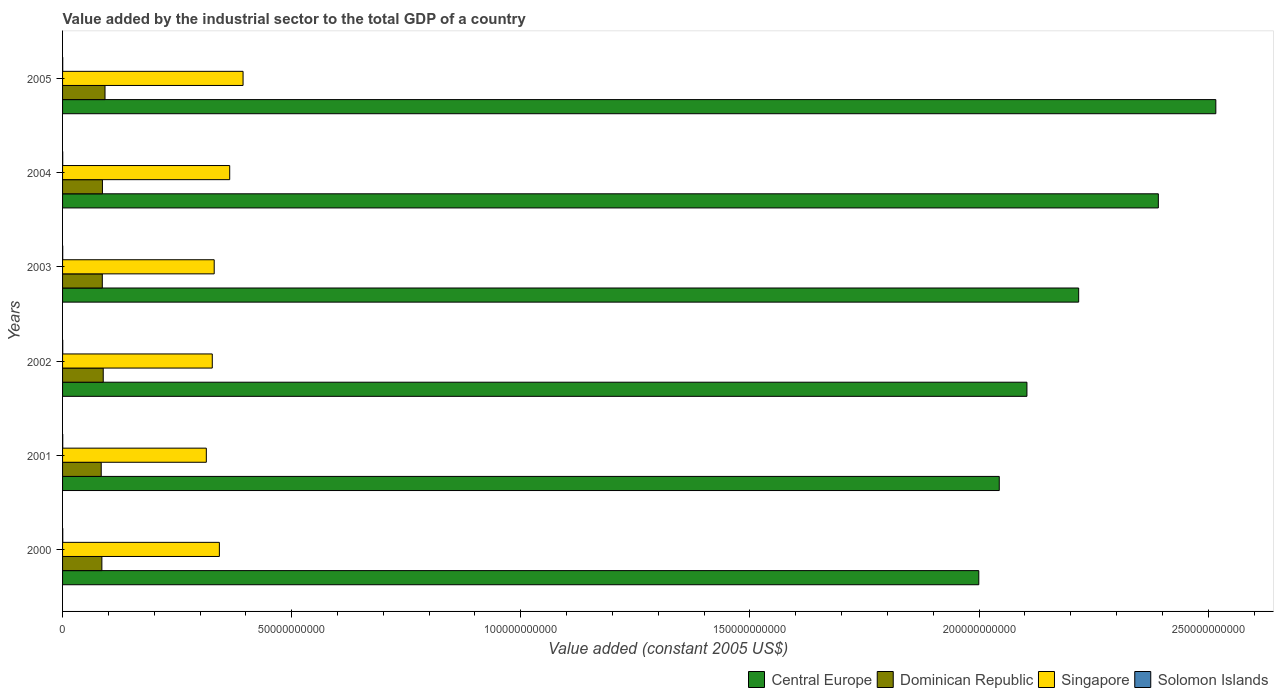Are the number of bars on each tick of the Y-axis equal?
Give a very brief answer. Yes. How many bars are there on the 2nd tick from the top?
Your answer should be compact. 4. What is the label of the 3rd group of bars from the top?
Your answer should be very brief. 2003. What is the value added by the industrial sector in Dominican Republic in 2005?
Keep it short and to the point. 9.26e+09. Across all years, what is the maximum value added by the industrial sector in Solomon Islands?
Keep it short and to the point. 4.19e+07. Across all years, what is the minimum value added by the industrial sector in Solomon Islands?
Your response must be concise. 3.20e+07. In which year was the value added by the industrial sector in Central Europe maximum?
Ensure brevity in your answer.  2005. In which year was the value added by the industrial sector in Singapore minimum?
Your response must be concise. 2001. What is the total value added by the industrial sector in Dominican Republic in the graph?
Make the answer very short. 5.25e+1. What is the difference between the value added by the industrial sector in Singapore in 2001 and that in 2005?
Your response must be concise. -8.01e+09. What is the difference between the value added by the industrial sector in Central Europe in 2005 and the value added by the industrial sector in Solomon Islands in 2000?
Keep it short and to the point. 2.52e+11. What is the average value added by the industrial sector in Dominican Republic per year?
Provide a short and direct response. 8.75e+09. In the year 2005, what is the difference between the value added by the industrial sector in Dominican Republic and value added by the industrial sector in Central Europe?
Your response must be concise. -2.42e+11. In how many years, is the value added by the industrial sector in Singapore greater than 90000000000 US$?
Your answer should be very brief. 0. What is the ratio of the value added by the industrial sector in Singapore in 2000 to that in 2004?
Your response must be concise. 0.94. Is the value added by the industrial sector in Dominican Republic in 2001 less than that in 2003?
Provide a short and direct response. Yes. Is the difference between the value added by the industrial sector in Dominican Republic in 2002 and 2003 greater than the difference between the value added by the industrial sector in Central Europe in 2002 and 2003?
Offer a very short reply. Yes. What is the difference between the highest and the second highest value added by the industrial sector in Dominican Republic?
Give a very brief answer. 3.90e+08. What is the difference between the highest and the lowest value added by the industrial sector in Central Europe?
Provide a short and direct response. 5.17e+1. In how many years, is the value added by the industrial sector in Dominican Republic greater than the average value added by the industrial sector in Dominican Republic taken over all years?
Ensure brevity in your answer.  2. What does the 3rd bar from the top in 2005 represents?
Your answer should be very brief. Dominican Republic. What does the 4th bar from the bottom in 2002 represents?
Provide a succinct answer. Solomon Islands. Is it the case that in every year, the sum of the value added by the industrial sector in Solomon Islands and value added by the industrial sector in Dominican Republic is greater than the value added by the industrial sector in Central Europe?
Ensure brevity in your answer.  No. How many bars are there?
Keep it short and to the point. 24. Are all the bars in the graph horizontal?
Your answer should be compact. Yes. What is the difference between two consecutive major ticks on the X-axis?
Offer a terse response. 5.00e+1. Are the values on the major ticks of X-axis written in scientific E-notation?
Offer a terse response. No. Where does the legend appear in the graph?
Your response must be concise. Bottom right. What is the title of the graph?
Provide a short and direct response. Value added by the industrial sector to the total GDP of a country. What is the label or title of the X-axis?
Your response must be concise. Value added (constant 2005 US$). What is the label or title of the Y-axis?
Give a very brief answer. Years. What is the Value added (constant 2005 US$) of Central Europe in 2000?
Provide a succinct answer. 2.00e+11. What is the Value added (constant 2005 US$) in Dominican Republic in 2000?
Offer a terse response. 8.58e+09. What is the Value added (constant 2005 US$) of Singapore in 2000?
Your answer should be compact. 3.42e+1. What is the Value added (constant 2005 US$) in Solomon Islands in 2000?
Ensure brevity in your answer.  4.19e+07. What is the Value added (constant 2005 US$) of Central Europe in 2001?
Provide a short and direct response. 2.04e+11. What is the Value added (constant 2005 US$) in Dominican Republic in 2001?
Your response must be concise. 8.43e+09. What is the Value added (constant 2005 US$) of Singapore in 2001?
Offer a very short reply. 3.14e+1. What is the Value added (constant 2005 US$) of Solomon Islands in 2001?
Your answer should be very brief. 3.80e+07. What is the Value added (constant 2005 US$) in Central Europe in 2002?
Make the answer very short. 2.10e+11. What is the Value added (constant 2005 US$) of Dominican Republic in 2002?
Give a very brief answer. 8.87e+09. What is the Value added (constant 2005 US$) of Singapore in 2002?
Provide a short and direct response. 3.27e+1. What is the Value added (constant 2005 US$) of Solomon Islands in 2002?
Your response must be concise. 3.70e+07. What is the Value added (constant 2005 US$) of Central Europe in 2003?
Offer a terse response. 2.22e+11. What is the Value added (constant 2005 US$) in Dominican Republic in 2003?
Give a very brief answer. 8.67e+09. What is the Value added (constant 2005 US$) in Singapore in 2003?
Provide a short and direct response. 3.31e+1. What is the Value added (constant 2005 US$) in Solomon Islands in 2003?
Keep it short and to the point. 3.43e+07. What is the Value added (constant 2005 US$) of Central Europe in 2004?
Offer a terse response. 2.39e+11. What is the Value added (constant 2005 US$) of Dominican Republic in 2004?
Provide a succinct answer. 8.70e+09. What is the Value added (constant 2005 US$) in Singapore in 2004?
Make the answer very short. 3.65e+1. What is the Value added (constant 2005 US$) of Solomon Islands in 2004?
Offer a terse response. 3.20e+07. What is the Value added (constant 2005 US$) in Central Europe in 2005?
Offer a terse response. 2.52e+11. What is the Value added (constant 2005 US$) of Dominican Republic in 2005?
Your response must be concise. 9.26e+09. What is the Value added (constant 2005 US$) in Singapore in 2005?
Your response must be concise. 3.94e+1. What is the Value added (constant 2005 US$) of Solomon Islands in 2005?
Your answer should be very brief. 3.29e+07. Across all years, what is the maximum Value added (constant 2005 US$) in Central Europe?
Provide a short and direct response. 2.52e+11. Across all years, what is the maximum Value added (constant 2005 US$) of Dominican Republic?
Offer a very short reply. 9.26e+09. Across all years, what is the maximum Value added (constant 2005 US$) of Singapore?
Keep it short and to the point. 3.94e+1. Across all years, what is the maximum Value added (constant 2005 US$) in Solomon Islands?
Your answer should be compact. 4.19e+07. Across all years, what is the minimum Value added (constant 2005 US$) of Central Europe?
Provide a succinct answer. 2.00e+11. Across all years, what is the minimum Value added (constant 2005 US$) in Dominican Republic?
Your answer should be compact. 8.43e+09. Across all years, what is the minimum Value added (constant 2005 US$) in Singapore?
Make the answer very short. 3.14e+1. Across all years, what is the minimum Value added (constant 2005 US$) of Solomon Islands?
Your answer should be compact. 3.20e+07. What is the total Value added (constant 2005 US$) in Central Europe in the graph?
Provide a succinct answer. 1.33e+12. What is the total Value added (constant 2005 US$) in Dominican Republic in the graph?
Keep it short and to the point. 5.25e+1. What is the total Value added (constant 2005 US$) of Singapore in the graph?
Make the answer very short. 2.07e+11. What is the total Value added (constant 2005 US$) in Solomon Islands in the graph?
Your response must be concise. 2.16e+08. What is the difference between the Value added (constant 2005 US$) in Central Europe in 2000 and that in 2001?
Offer a terse response. -4.47e+09. What is the difference between the Value added (constant 2005 US$) in Dominican Republic in 2000 and that in 2001?
Give a very brief answer. 1.43e+08. What is the difference between the Value added (constant 2005 US$) in Singapore in 2000 and that in 2001?
Make the answer very short. 2.84e+09. What is the difference between the Value added (constant 2005 US$) of Solomon Islands in 2000 and that in 2001?
Your answer should be compact. 3.89e+06. What is the difference between the Value added (constant 2005 US$) in Central Europe in 2000 and that in 2002?
Offer a very short reply. -1.05e+1. What is the difference between the Value added (constant 2005 US$) of Dominican Republic in 2000 and that in 2002?
Give a very brief answer. -2.97e+08. What is the difference between the Value added (constant 2005 US$) of Singapore in 2000 and that in 2002?
Give a very brief answer. 1.55e+09. What is the difference between the Value added (constant 2005 US$) in Solomon Islands in 2000 and that in 2002?
Give a very brief answer. 4.82e+06. What is the difference between the Value added (constant 2005 US$) of Central Europe in 2000 and that in 2003?
Offer a very short reply. -2.18e+1. What is the difference between the Value added (constant 2005 US$) of Dominican Republic in 2000 and that in 2003?
Provide a short and direct response. -9.49e+07. What is the difference between the Value added (constant 2005 US$) of Singapore in 2000 and that in 2003?
Keep it short and to the point. 1.13e+09. What is the difference between the Value added (constant 2005 US$) in Solomon Islands in 2000 and that in 2003?
Offer a very short reply. 7.56e+06. What is the difference between the Value added (constant 2005 US$) in Central Europe in 2000 and that in 2004?
Give a very brief answer. -3.92e+1. What is the difference between the Value added (constant 2005 US$) in Dominican Republic in 2000 and that in 2004?
Keep it short and to the point. -1.23e+08. What is the difference between the Value added (constant 2005 US$) in Singapore in 2000 and that in 2004?
Give a very brief answer. -2.26e+09. What is the difference between the Value added (constant 2005 US$) in Solomon Islands in 2000 and that in 2004?
Keep it short and to the point. 9.82e+06. What is the difference between the Value added (constant 2005 US$) in Central Europe in 2000 and that in 2005?
Offer a terse response. -5.17e+1. What is the difference between the Value added (constant 2005 US$) of Dominican Republic in 2000 and that in 2005?
Your response must be concise. -6.87e+08. What is the difference between the Value added (constant 2005 US$) of Singapore in 2000 and that in 2005?
Your answer should be very brief. -5.17e+09. What is the difference between the Value added (constant 2005 US$) of Solomon Islands in 2000 and that in 2005?
Make the answer very short. 8.97e+06. What is the difference between the Value added (constant 2005 US$) of Central Europe in 2001 and that in 2002?
Keep it short and to the point. -6.04e+09. What is the difference between the Value added (constant 2005 US$) in Dominican Republic in 2001 and that in 2002?
Give a very brief answer. -4.40e+08. What is the difference between the Value added (constant 2005 US$) of Singapore in 2001 and that in 2002?
Provide a succinct answer. -1.30e+09. What is the difference between the Value added (constant 2005 US$) of Solomon Islands in 2001 and that in 2002?
Provide a succinct answer. 9.35e+05. What is the difference between the Value added (constant 2005 US$) in Central Europe in 2001 and that in 2003?
Offer a terse response. -1.73e+1. What is the difference between the Value added (constant 2005 US$) in Dominican Republic in 2001 and that in 2003?
Make the answer very short. -2.38e+08. What is the difference between the Value added (constant 2005 US$) in Singapore in 2001 and that in 2003?
Ensure brevity in your answer.  -1.72e+09. What is the difference between the Value added (constant 2005 US$) of Solomon Islands in 2001 and that in 2003?
Your response must be concise. 3.68e+06. What is the difference between the Value added (constant 2005 US$) in Central Europe in 2001 and that in 2004?
Provide a short and direct response. -3.47e+1. What is the difference between the Value added (constant 2005 US$) in Dominican Republic in 2001 and that in 2004?
Offer a very short reply. -2.65e+08. What is the difference between the Value added (constant 2005 US$) of Singapore in 2001 and that in 2004?
Your answer should be very brief. -5.10e+09. What is the difference between the Value added (constant 2005 US$) in Solomon Islands in 2001 and that in 2004?
Your response must be concise. 5.93e+06. What is the difference between the Value added (constant 2005 US$) in Central Europe in 2001 and that in 2005?
Give a very brief answer. -4.73e+1. What is the difference between the Value added (constant 2005 US$) of Dominican Republic in 2001 and that in 2005?
Your answer should be compact. -8.30e+08. What is the difference between the Value added (constant 2005 US$) of Singapore in 2001 and that in 2005?
Your answer should be compact. -8.01e+09. What is the difference between the Value added (constant 2005 US$) of Solomon Islands in 2001 and that in 2005?
Offer a terse response. 5.08e+06. What is the difference between the Value added (constant 2005 US$) of Central Europe in 2002 and that in 2003?
Offer a terse response. -1.13e+1. What is the difference between the Value added (constant 2005 US$) of Dominican Republic in 2002 and that in 2003?
Your answer should be compact. 2.02e+08. What is the difference between the Value added (constant 2005 US$) in Singapore in 2002 and that in 2003?
Provide a succinct answer. -4.20e+08. What is the difference between the Value added (constant 2005 US$) in Solomon Islands in 2002 and that in 2003?
Your answer should be very brief. 2.74e+06. What is the difference between the Value added (constant 2005 US$) of Central Europe in 2002 and that in 2004?
Offer a terse response. -2.87e+1. What is the difference between the Value added (constant 2005 US$) in Dominican Republic in 2002 and that in 2004?
Offer a very short reply. 1.74e+08. What is the difference between the Value added (constant 2005 US$) in Singapore in 2002 and that in 2004?
Provide a short and direct response. -3.80e+09. What is the difference between the Value added (constant 2005 US$) of Solomon Islands in 2002 and that in 2004?
Your answer should be very brief. 5.00e+06. What is the difference between the Value added (constant 2005 US$) in Central Europe in 2002 and that in 2005?
Make the answer very short. -4.12e+1. What is the difference between the Value added (constant 2005 US$) in Dominican Republic in 2002 and that in 2005?
Your answer should be very brief. -3.90e+08. What is the difference between the Value added (constant 2005 US$) of Singapore in 2002 and that in 2005?
Provide a succinct answer. -6.72e+09. What is the difference between the Value added (constant 2005 US$) of Solomon Islands in 2002 and that in 2005?
Give a very brief answer. 4.15e+06. What is the difference between the Value added (constant 2005 US$) in Central Europe in 2003 and that in 2004?
Your answer should be very brief. -1.74e+1. What is the difference between the Value added (constant 2005 US$) in Dominican Republic in 2003 and that in 2004?
Ensure brevity in your answer.  -2.77e+07. What is the difference between the Value added (constant 2005 US$) of Singapore in 2003 and that in 2004?
Provide a succinct answer. -3.38e+09. What is the difference between the Value added (constant 2005 US$) in Solomon Islands in 2003 and that in 2004?
Keep it short and to the point. 2.26e+06. What is the difference between the Value added (constant 2005 US$) of Central Europe in 2003 and that in 2005?
Your answer should be very brief. -2.99e+1. What is the difference between the Value added (constant 2005 US$) in Dominican Republic in 2003 and that in 2005?
Provide a succinct answer. -5.92e+08. What is the difference between the Value added (constant 2005 US$) in Singapore in 2003 and that in 2005?
Keep it short and to the point. -6.30e+09. What is the difference between the Value added (constant 2005 US$) of Solomon Islands in 2003 and that in 2005?
Your answer should be very brief. 1.41e+06. What is the difference between the Value added (constant 2005 US$) in Central Europe in 2004 and that in 2005?
Your answer should be very brief. -1.25e+1. What is the difference between the Value added (constant 2005 US$) of Dominican Republic in 2004 and that in 2005?
Your answer should be very brief. -5.64e+08. What is the difference between the Value added (constant 2005 US$) of Singapore in 2004 and that in 2005?
Your answer should be very brief. -2.91e+09. What is the difference between the Value added (constant 2005 US$) of Solomon Islands in 2004 and that in 2005?
Ensure brevity in your answer.  -8.51e+05. What is the difference between the Value added (constant 2005 US$) in Central Europe in 2000 and the Value added (constant 2005 US$) in Dominican Republic in 2001?
Provide a succinct answer. 1.92e+11. What is the difference between the Value added (constant 2005 US$) in Central Europe in 2000 and the Value added (constant 2005 US$) in Singapore in 2001?
Your response must be concise. 1.69e+11. What is the difference between the Value added (constant 2005 US$) of Central Europe in 2000 and the Value added (constant 2005 US$) of Solomon Islands in 2001?
Your answer should be compact. 2.00e+11. What is the difference between the Value added (constant 2005 US$) in Dominican Republic in 2000 and the Value added (constant 2005 US$) in Singapore in 2001?
Offer a terse response. -2.28e+1. What is the difference between the Value added (constant 2005 US$) in Dominican Republic in 2000 and the Value added (constant 2005 US$) in Solomon Islands in 2001?
Ensure brevity in your answer.  8.54e+09. What is the difference between the Value added (constant 2005 US$) of Singapore in 2000 and the Value added (constant 2005 US$) of Solomon Islands in 2001?
Make the answer very short. 3.42e+1. What is the difference between the Value added (constant 2005 US$) of Central Europe in 2000 and the Value added (constant 2005 US$) of Dominican Republic in 2002?
Your answer should be very brief. 1.91e+11. What is the difference between the Value added (constant 2005 US$) in Central Europe in 2000 and the Value added (constant 2005 US$) in Singapore in 2002?
Provide a short and direct response. 1.67e+11. What is the difference between the Value added (constant 2005 US$) of Central Europe in 2000 and the Value added (constant 2005 US$) of Solomon Islands in 2002?
Provide a short and direct response. 2.00e+11. What is the difference between the Value added (constant 2005 US$) in Dominican Republic in 2000 and the Value added (constant 2005 US$) in Singapore in 2002?
Provide a succinct answer. -2.41e+1. What is the difference between the Value added (constant 2005 US$) in Dominican Republic in 2000 and the Value added (constant 2005 US$) in Solomon Islands in 2002?
Offer a terse response. 8.54e+09. What is the difference between the Value added (constant 2005 US$) in Singapore in 2000 and the Value added (constant 2005 US$) in Solomon Islands in 2002?
Provide a short and direct response. 3.42e+1. What is the difference between the Value added (constant 2005 US$) in Central Europe in 2000 and the Value added (constant 2005 US$) in Dominican Republic in 2003?
Your answer should be compact. 1.91e+11. What is the difference between the Value added (constant 2005 US$) of Central Europe in 2000 and the Value added (constant 2005 US$) of Singapore in 2003?
Keep it short and to the point. 1.67e+11. What is the difference between the Value added (constant 2005 US$) in Central Europe in 2000 and the Value added (constant 2005 US$) in Solomon Islands in 2003?
Your answer should be very brief. 2.00e+11. What is the difference between the Value added (constant 2005 US$) in Dominican Republic in 2000 and the Value added (constant 2005 US$) in Singapore in 2003?
Offer a terse response. -2.45e+1. What is the difference between the Value added (constant 2005 US$) in Dominican Republic in 2000 and the Value added (constant 2005 US$) in Solomon Islands in 2003?
Offer a very short reply. 8.54e+09. What is the difference between the Value added (constant 2005 US$) in Singapore in 2000 and the Value added (constant 2005 US$) in Solomon Islands in 2003?
Keep it short and to the point. 3.42e+1. What is the difference between the Value added (constant 2005 US$) of Central Europe in 2000 and the Value added (constant 2005 US$) of Dominican Republic in 2004?
Offer a very short reply. 1.91e+11. What is the difference between the Value added (constant 2005 US$) in Central Europe in 2000 and the Value added (constant 2005 US$) in Singapore in 2004?
Offer a very short reply. 1.63e+11. What is the difference between the Value added (constant 2005 US$) in Central Europe in 2000 and the Value added (constant 2005 US$) in Solomon Islands in 2004?
Offer a terse response. 2.00e+11. What is the difference between the Value added (constant 2005 US$) of Dominican Republic in 2000 and the Value added (constant 2005 US$) of Singapore in 2004?
Your answer should be very brief. -2.79e+1. What is the difference between the Value added (constant 2005 US$) in Dominican Republic in 2000 and the Value added (constant 2005 US$) in Solomon Islands in 2004?
Your answer should be compact. 8.55e+09. What is the difference between the Value added (constant 2005 US$) in Singapore in 2000 and the Value added (constant 2005 US$) in Solomon Islands in 2004?
Offer a very short reply. 3.42e+1. What is the difference between the Value added (constant 2005 US$) of Central Europe in 2000 and the Value added (constant 2005 US$) of Dominican Republic in 2005?
Ensure brevity in your answer.  1.91e+11. What is the difference between the Value added (constant 2005 US$) of Central Europe in 2000 and the Value added (constant 2005 US$) of Singapore in 2005?
Make the answer very short. 1.61e+11. What is the difference between the Value added (constant 2005 US$) in Central Europe in 2000 and the Value added (constant 2005 US$) in Solomon Islands in 2005?
Make the answer very short. 2.00e+11. What is the difference between the Value added (constant 2005 US$) of Dominican Republic in 2000 and the Value added (constant 2005 US$) of Singapore in 2005?
Offer a terse response. -3.08e+1. What is the difference between the Value added (constant 2005 US$) in Dominican Republic in 2000 and the Value added (constant 2005 US$) in Solomon Islands in 2005?
Ensure brevity in your answer.  8.54e+09. What is the difference between the Value added (constant 2005 US$) in Singapore in 2000 and the Value added (constant 2005 US$) in Solomon Islands in 2005?
Provide a short and direct response. 3.42e+1. What is the difference between the Value added (constant 2005 US$) of Central Europe in 2001 and the Value added (constant 2005 US$) of Dominican Republic in 2002?
Your response must be concise. 1.96e+11. What is the difference between the Value added (constant 2005 US$) in Central Europe in 2001 and the Value added (constant 2005 US$) in Singapore in 2002?
Ensure brevity in your answer.  1.72e+11. What is the difference between the Value added (constant 2005 US$) of Central Europe in 2001 and the Value added (constant 2005 US$) of Solomon Islands in 2002?
Offer a very short reply. 2.04e+11. What is the difference between the Value added (constant 2005 US$) in Dominican Republic in 2001 and the Value added (constant 2005 US$) in Singapore in 2002?
Make the answer very short. -2.42e+1. What is the difference between the Value added (constant 2005 US$) in Dominican Republic in 2001 and the Value added (constant 2005 US$) in Solomon Islands in 2002?
Keep it short and to the point. 8.40e+09. What is the difference between the Value added (constant 2005 US$) in Singapore in 2001 and the Value added (constant 2005 US$) in Solomon Islands in 2002?
Make the answer very short. 3.13e+1. What is the difference between the Value added (constant 2005 US$) in Central Europe in 2001 and the Value added (constant 2005 US$) in Dominican Republic in 2003?
Give a very brief answer. 1.96e+11. What is the difference between the Value added (constant 2005 US$) of Central Europe in 2001 and the Value added (constant 2005 US$) of Singapore in 2003?
Offer a terse response. 1.71e+11. What is the difference between the Value added (constant 2005 US$) in Central Europe in 2001 and the Value added (constant 2005 US$) in Solomon Islands in 2003?
Your response must be concise. 2.04e+11. What is the difference between the Value added (constant 2005 US$) of Dominican Republic in 2001 and the Value added (constant 2005 US$) of Singapore in 2003?
Your answer should be compact. -2.47e+1. What is the difference between the Value added (constant 2005 US$) in Dominican Republic in 2001 and the Value added (constant 2005 US$) in Solomon Islands in 2003?
Your answer should be compact. 8.40e+09. What is the difference between the Value added (constant 2005 US$) in Singapore in 2001 and the Value added (constant 2005 US$) in Solomon Islands in 2003?
Offer a very short reply. 3.13e+1. What is the difference between the Value added (constant 2005 US$) of Central Europe in 2001 and the Value added (constant 2005 US$) of Dominican Republic in 2004?
Your response must be concise. 1.96e+11. What is the difference between the Value added (constant 2005 US$) in Central Europe in 2001 and the Value added (constant 2005 US$) in Singapore in 2004?
Your answer should be compact. 1.68e+11. What is the difference between the Value added (constant 2005 US$) of Central Europe in 2001 and the Value added (constant 2005 US$) of Solomon Islands in 2004?
Your response must be concise. 2.04e+11. What is the difference between the Value added (constant 2005 US$) in Dominican Republic in 2001 and the Value added (constant 2005 US$) in Singapore in 2004?
Offer a terse response. -2.80e+1. What is the difference between the Value added (constant 2005 US$) of Dominican Republic in 2001 and the Value added (constant 2005 US$) of Solomon Islands in 2004?
Make the answer very short. 8.40e+09. What is the difference between the Value added (constant 2005 US$) of Singapore in 2001 and the Value added (constant 2005 US$) of Solomon Islands in 2004?
Provide a succinct answer. 3.13e+1. What is the difference between the Value added (constant 2005 US$) in Central Europe in 2001 and the Value added (constant 2005 US$) in Dominican Republic in 2005?
Your answer should be compact. 1.95e+11. What is the difference between the Value added (constant 2005 US$) of Central Europe in 2001 and the Value added (constant 2005 US$) of Singapore in 2005?
Provide a succinct answer. 1.65e+11. What is the difference between the Value added (constant 2005 US$) of Central Europe in 2001 and the Value added (constant 2005 US$) of Solomon Islands in 2005?
Your answer should be very brief. 2.04e+11. What is the difference between the Value added (constant 2005 US$) in Dominican Republic in 2001 and the Value added (constant 2005 US$) in Singapore in 2005?
Provide a succinct answer. -3.10e+1. What is the difference between the Value added (constant 2005 US$) in Dominican Republic in 2001 and the Value added (constant 2005 US$) in Solomon Islands in 2005?
Your answer should be compact. 8.40e+09. What is the difference between the Value added (constant 2005 US$) in Singapore in 2001 and the Value added (constant 2005 US$) in Solomon Islands in 2005?
Give a very brief answer. 3.13e+1. What is the difference between the Value added (constant 2005 US$) of Central Europe in 2002 and the Value added (constant 2005 US$) of Dominican Republic in 2003?
Make the answer very short. 2.02e+11. What is the difference between the Value added (constant 2005 US$) of Central Europe in 2002 and the Value added (constant 2005 US$) of Singapore in 2003?
Your response must be concise. 1.77e+11. What is the difference between the Value added (constant 2005 US$) of Central Europe in 2002 and the Value added (constant 2005 US$) of Solomon Islands in 2003?
Your answer should be very brief. 2.10e+11. What is the difference between the Value added (constant 2005 US$) of Dominican Republic in 2002 and the Value added (constant 2005 US$) of Singapore in 2003?
Ensure brevity in your answer.  -2.42e+1. What is the difference between the Value added (constant 2005 US$) in Dominican Republic in 2002 and the Value added (constant 2005 US$) in Solomon Islands in 2003?
Your answer should be very brief. 8.84e+09. What is the difference between the Value added (constant 2005 US$) of Singapore in 2002 and the Value added (constant 2005 US$) of Solomon Islands in 2003?
Provide a short and direct response. 3.26e+1. What is the difference between the Value added (constant 2005 US$) of Central Europe in 2002 and the Value added (constant 2005 US$) of Dominican Republic in 2004?
Give a very brief answer. 2.02e+11. What is the difference between the Value added (constant 2005 US$) in Central Europe in 2002 and the Value added (constant 2005 US$) in Singapore in 2004?
Provide a succinct answer. 1.74e+11. What is the difference between the Value added (constant 2005 US$) in Central Europe in 2002 and the Value added (constant 2005 US$) in Solomon Islands in 2004?
Provide a succinct answer. 2.10e+11. What is the difference between the Value added (constant 2005 US$) in Dominican Republic in 2002 and the Value added (constant 2005 US$) in Singapore in 2004?
Your answer should be compact. -2.76e+1. What is the difference between the Value added (constant 2005 US$) in Dominican Republic in 2002 and the Value added (constant 2005 US$) in Solomon Islands in 2004?
Keep it short and to the point. 8.84e+09. What is the difference between the Value added (constant 2005 US$) in Singapore in 2002 and the Value added (constant 2005 US$) in Solomon Islands in 2004?
Give a very brief answer. 3.26e+1. What is the difference between the Value added (constant 2005 US$) in Central Europe in 2002 and the Value added (constant 2005 US$) in Dominican Republic in 2005?
Offer a terse response. 2.01e+11. What is the difference between the Value added (constant 2005 US$) in Central Europe in 2002 and the Value added (constant 2005 US$) in Singapore in 2005?
Offer a very short reply. 1.71e+11. What is the difference between the Value added (constant 2005 US$) of Central Europe in 2002 and the Value added (constant 2005 US$) of Solomon Islands in 2005?
Offer a terse response. 2.10e+11. What is the difference between the Value added (constant 2005 US$) in Dominican Republic in 2002 and the Value added (constant 2005 US$) in Singapore in 2005?
Offer a very short reply. -3.05e+1. What is the difference between the Value added (constant 2005 US$) in Dominican Republic in 2002 and the Value added (constant 2005 US$) in Solomon Islands in 2005?
Offer a terse response. 8.84e+09. What is the difference between the Value added (constant 2005 US$) of Singapore in 2002 and the Value added (constant 2005 US$) of Solomon Islands in 2005?
Keep it short and to the point. 3.26e+1. What is the difference between the Value added (constant 2005 US$) of Central Europe in 2003 and the Value added (constant 2005 US$) of Dominican Republic in 2004?
Your answer should be very brief. 2.13e+11. What is the difference between the Value added (constant 2005 US$) of Central Europe in 2003 and the Value added (constant 2005 US$) of Singapore in 2004?
Your answer should be compact. 1.85e+11. What is the difference between the Value added (constant 2005 US$) of Central Europe in 2003 and the Value added (constant 2005 US$) of Solomon Islands in 2004?
Ensure brevity in your answer.  2.22e+11. What is the difference between the Value added (constant 2005 US$) in Dominican Republic in 2003 and the Value added (constant 2005 US$) in Singapore in 2004?
Make the answer very short. -2.78e+1. What is the difference between the Value added (constant 2005 US$) of Dominican Republic in 2003 and the Value added (constant 2005 US$) of Solomon Islands in 2004?
Give a very brief answer. 8.64e+09. What is the difference between the Value added (constant 2005 US$) of Singapore in 2003 and the Value added (constant 2005 US$) of Solomon Islands in 2004?
Provide a short and direct response. 3.31e+1. What is the difference between the Value added (constant 2005 US$) in Central Europe in 2003 and the Value added (constant 2005 US$) in Dominican Republic in 2005?
Your answer should be very brief. 2.12e+11. What is the difference between the Value added (constant 2005 US$) of Central Europe in 2003 and the Value added (constant 2005 US$) of Singapore in 2005?
Your response must be concise. 1.82e+11. What is the difference between the Value added (constant 2005 US$) in Central Europe in 2003 and the Value added (constant 2005 US$) in Solomon Islands in 2005?
Your answer should be very brief. 2.22e+11. What is the difference between the Value added (constant 2005 US$) in Dominican Republic in 2003 and the Value added (constant 2005 US$) in Singapore in 2005?
Your response must be concise. -3.07e+1. What is the difference between the Value added (constant 2005 US$) of Dominican Republic in 2003 and the Value added (constant 2005 US$) of Solomon Islands in 2005?
Offer a very short reply. 8.64e+09. What is the difference between the Value added (constant 2005 US$) of Singapore in 2003 and the Value added (constant 2005 US$) of Solomon Islands in 2005?
Offer a terse response. 3.31e+1. What is the difference between the Value added (constant 2005 US$) in Central Europe in 2004 and the Value added (constant 2005 US$) in Dominican Republic in 2005?
Keep it short and to the point. 2.30e+11. What is the difference between the Value added (constant 2005 US$) in Central Europe in 2004 and the Value added (constant 2005 US$) in Singapore in 2005?
Make the answer very short. 2.00e+11. What is the difference between the Value added (constant 2005 US$) of Central Europe in 2004 and the Value added (constant 2005 US$) of Solomon Islands in 2005?
Offer a very short reply. 2.39e+11. What is the difference between the Value added (constant 2005 US$) in Dominican Republic in 2004 and the Value added (constant 2005 US$) in Singapore in 2005?
Your answer should be compact. -3.07e+1. What is the difference between the Value added (constant 2005 US$) in Dominican Republic in 2004 and the Value added (constant 2005 US$) in Solomon Islands in 2005?
Keep it short and to the point. 8.67e+09. What is the difference between the Value added (constant 2005 US$) in Singapore in 2004 and the Value added (constant 2005 US$) in Solomon Islands in 2005?
Keep it short and to the point. 3.64e+1. What is the average Value added (constant 2005 US$) of Central Europe per year?
Your response must be concise. 2.21e+11. What is the average Value added (constant 2005 US$) in Dominican Republic per year?
Your answer should be compact. 8.75e+09. What is the average Value added (constant 2005 US$) in Singapore per year?
Offer a very short reply. 3.45e+1. What is the average Value added (constant 2005 US$) in Solomon Islands per year?
Offer a terse response. 3.60e+07. In the year 2000, what is the difference between the Value added (constant 2005 US$) of Central Europe and Value added (constant 2005 US$) of Dominican Republic?
Keep it short and to the point. 1.91e+11. In the year 2000, what is the difference between the Value added (constant 2005 US$) in Central Europe and Value added (constant 2005 US$) in Singapore?
Keep it short and to the point. 1.66e+11. In the year 2000, what is the difference between the Value added (constant 2005 US$) in Central Europe and Value added (constant 2005 US$) in Solomon Islands?
Give a very brief answer. 2.00e+11. In the year 2000, what is the difference between the Value added (constant 2005 US$) in Dominican Republic and Value added (constant 2005 US$) in Singapore?
Make the answer very short. -2.56e+1. In the year 2000, what is the difference between the Value added (constant 2005 US$) of Dominican Republic and Value added (constant 2005 US$) of Solomon Islands?
Provide a succinct answer. 8.54e+09. In the year 2000, what is the difference between the Value added (constant 2005 US$) in Singapore and Value added (constant 2005 US$) in Solomon Islands?
Provide a succinct answer. 3.42e+1. In the year 2001, what is the difference between the Value added (constant 2005 US$) of Central Europe and Value added (constant 2005 US$) of Dominican Republic?
Offer a very short reply. 1.96e+11. In the year 2001, what is the difference between the Value added (constant 2005 US$) in Central Europe and Value added (constant 2005 US$) in Singapore?
Provide a succinct answer. 1.73e+11. In the year 2001, what is the difference between the Value added (constant 2005 US$) in Central Europe and Value added (constant 2005 US$) in Solomon Islands?
Your response must be concise. 2.04e+11. In the year 2001, what is the difference between the Value added (constant 2005 US$) in Dominican Republic and Value added (constant 2005 US$) in Singapore?
Provide a short and direct response. -2.29e+1. In the year 2001, what is the difference between the Value added (constant 2005 US$) of Dominican Republic and Value added (constant 2005 US$) of Solomon Islands?
Ensure brevity in your answer.  8.40e+09. In the year 2001, what is the difference between the Value added (constant 2005 US$) in Singapore and Value added (constant 2005 US$) in Solomon Islands?
Ensure brevity in your answer.  3.13e+1. In the year 2002, what is the difference between the Value added (constant 2005 US$) of Central Europe and Value added (constant 2005 US$) of Dominican Republic?
Offer a terse response. 2.02e+11. In the year 2002, what is the difference between the Value added (constant 2005 US$) in Central Europe and Value added (constant 2005 US$) in Singapore?
Make the answer very short. 1.78e+11. In the year 2002, what is the difference between the Value added (constant 2005 US$) in Central Europe and Value added (constant 2005 US$) in Solomon Islands?
Give a very brief answer. 2.10e+11. In the year 2002, what is the difference between the Value added (constant 2005 US$) in Dominican Republic and Value added (constant 2005 US$) in Singapore?
Your answer should be very brief. -2.38e+1. In the year 2002, what is the difference between the Value added (constant 2005 US$) in Dominican Republic and Value added (constant 2005 US$) in Solomon Islands?
Keep it short and to the point. 8.84e+09. In the year 2002, what is the difference between the Value added (constant 2005 US$) of Singapore and Value added (constant 2005 US$) of Solomon Islands?
Offer a terse response. 3.26e+1. In the year 2003, what is the difference between the Value added (constant 2005 US$) in Central Europe and Value added (constant 2005 US$) in Dominican Republic?
Your answer should be compact. 2.13e+11. In the year 2003, what is the difference between the Value added (constant 2005 US$) of Central Europe and Value added (constant 2005 US$) of Singapore?
Ensure brevity in your answer.  1.89e+11. In the year 2003, what is the difference between the Value added (constant 2005 US$) of Central Europe and Value added (constant 2005 US$) of Solomon Islands?
Keep it short and to the point. 2.22e+11. In the year 2003, what is the difference between the Value added (constant 2005 US$) of Dominican Republic and Value added (constant 2005 US$) of Singapore?
Provide a succinct answer. -2.44e+1. In the year 2003, what is the difference between the Value added (constant 2005 US$) of Dominican Republic and Value added (constant 2005 US$) of Solomon Islands?
Give a very brief answer. 8.64e+09. In the year 2003, what is the difference between the Value added (constant 2005 US$) in Singapore and Value added (constant 2005 US$) in Solomon Islands?
Ensure brevity in your answer.  3.31e+1. In the year 2004, what is the difference between the Value added (constant 2005 US$) of Central Europe and Value added (constant 2005 US$) of Dominican Republic?
Provide a succinct answer. 2.30e+11. In the year 2004, what is the difference between the Value added (constant 2005 US$) of Central Europe and Value added (constant 2005 US$) of Singapore?
Provide a short and direct response. 2.03e+11. In the year 2004, what is the difference between the Value added (constant 2005 US$) in Central Europe and Value added (constant 2005 US$) in Solomon Islands?
Provide a short and direct response. 2.39e+11. In the year 2004, what is the difference between the Value added (constant 2005 US$) of Dominican Republic and Value added (constant 2005 US$) of Singapore?
Offer a very short reply. -2.78e+1. In the year 2004, what is the difference between the Value added (constant 2005 US$) in Dominican Republic and Value added (constant 2005 US$) in Solomon Islands?
Provide a succinct answer. 8.67e+09. In the year 2004, what is the difference between the Value added (constant 2005 US$) in Singapore and Value added (constant 2005 US$) in Solomon Islands?
Give a very brief answer. 3.64e+1. In the year 2005, what is the difference between the Value added (constant 2005 US$) of Central Europe and Value added (constant 2005 US$) of Dominican Republic?
Provide a succinct answer. 2.42e+11. In the year 2005, what is the difference between the Value added (constant 2005 US$) in Central Europe and Value added (constant 2005 US$) in Singapore?
Your response must be concise. 2.12e+11. In the year 2005, what is the difference between the Value added (constant 2005 US$) in Central Europe and Value added (constant 2005 US$) in Solomon Islands?
Offer a terse response. 2.52e+11. In the year 2005, what is the difference between the Value added (constant 2005 US$) in Dominican Republic and Value added (constant 2005 US$) in Singapore?
Your response must be concise. -3.01e+1. In the year 2005, what is the difference between the Value added (constant 2005 US$) of Dominican Republic and Value added (constant 2005 US$) of Solomon Islands?
Offer a terse response. 9.23e+09. In the year 2005, what is the difference between the Value added (constant 2005 US$) in Singapore and Value added (constant 2005 US$) in Solomon Islands?
Ensure brevity in your answer.  3.94e+1. What is the ratio of the Value added (constant 2005 US$) in Central Europe in 2000 to that in 2001?
Offer a terse response. 0.98. What is the ratio of the Value added (constant 2005 US$) in Dominican Republic in 2000 to that in 2001?
Offer a very short reply. 1.02. What is the ratio of the Value added (constant 2005 US$) of Singapore in 2000 to that in 2001?
Offer a terse response. 1.09. What is the ratio of the Value added (constant 2005 US$) in Solomon Islands in 2000 to that in 2001?
Your response must be concise. 1.1. What is the ratio of the Value added (constant 2005 US$) in Central Europe in 2000 to that in 2002?
Keep it short and to the point. 0.95. What is the ratio of the Value added (constant 2005 US$) in Dominican Republic in 2000 to that in 2002?
Give a very brief answer. 0.97. What is the ratio of the Value added (constant 2005 US$) in Singapore in 2000 to that in 2002?
Offer a terse response. 1.05. What is the ratio of the Value added (constant 2005 US$) in Solomon Islands in 2000 to that in 2002?
Make the answer very short. 1.13. What is the ratio of the Value added (constant 2005 US$) in Central Europe in 2000 to that in 2003?
Your answer should be very brief. 0.9. What is the ratio of the Value added (constant 2005 US$) in Singapore in 2000 to that in 2003?
Provide a succinct answer. 1.03. What is the ratio of the Value added (constant 2005 US$) of Solomon Islands in 2000 to that in 2003?
Offer a very short reply. 1.22. What is the ratio of the Value added (constant 2005 US$) of Central Europe in 2000 to that in 2004?
Give a very brief answer. 0.84. What is the ratio of the Value added (constant 2005 US$) in Dominican Republic in 2000 to that in 2004?
Give a very brief answer. 0.99. What is the ratio of the Value added (constant 2005 US$) of Singapore in 2000 to that in 2004?
Provide a succinct answer. 0.94. What is the ratio of the Value added (constant 2005 US$) of Solomon Islands in 2000 to that in 2004?
Provide a succinct answer. 1.31. What is the ratio of the Value added (constant 2005 US$) in Central Europe in 2000 to that in 2005?
Give a very brief answer. 0.79. What is the ratio of the Value added (constant 2005 US$) of Dominican Republic in 2000 to that in 2005?
Give a very brief answer. 0.93. What is the ratio of the Value added (constant 2005 US$) of Singapore in 2000 to that in 2005?
Your response must be concise. 0.87. What is the ratio of the Value added (constant 2005 US$) in Solomon Islands in 2000 to that in 2005?
Give a very brief answer. 1.27. What is the ratio of the Value added (constant 2005 US$) of Central Europe in 2001 to that in 2002?
Offer a very short reply. 0.97. What is the ratio of the Value added (constant 2005 US$) in Dominican Republic in 2001 to that in 2002?
Your answer should be very brief. 0.95. What is the ratio of the Value added (constant 2005 US$) of Singapore in 2001 to that in 2002?
Provide a succinct answer. 0.96. What is the ratio of the Value added (constant 2005 US$) in Solomon Islands in 2001 to that in 2002?
Your answer should be compact. 1.03. What is the ratio of the Value added (constant 2005 US$) of Central Europe in 2001 to that in 2003?
Provide a succinct answer. 0.92. What is the ratio of the Value added (constant 2005 US$) in Dominican Republic in 2001 to that in 2003?
Ensure brevity in your answer.  0.97. What is the ratio of the Value added (constant 2005 US$) of Singapore in 2001 to that in 2003?
Your response must be concise. 0.95. What is the ratio of the Value added (constant 2005 US$) in Solomon Islands in 2001 to that in 2003?
Your answer should be very brief. 1.11. What is the ratio of the Value added (constant 2005 US$) in Central Europe in 2001 to that in 2004?
Your answer should be compact. 0.85. What is the ratio of the Value added (constant 2005 US$) in Dominican Republic in 2001 to that in 2004?
Provide a succinct answer. 0.97. What is the ratio of the Value added (constant 2005 US$) of Singapore in 2001 to that in 2004?
Provide a short and direct response. 0.86. What is the ratio of the Value added (constant 2005 US$) of Solomon Islands in 2001 to that in 2004?
Your answer should be compact. 1.19. What is the ratio of the Value added (constant 2005 US$) of Central Europe in 2001 to that in 2005?
Provide a short and direct response. 0.81. What is the ratio of the Value added (constant 2005 US$) in Dominican Republic in 2001 to that in 2005?
Your answer should be compact. 0.91. What is the ratio of the Value added (constant 2005 US$) in Singapore in 2001 to that in 2005?
Offer a terse response. 0.8. What is the ratio of the Value added (constant 2005 US$) in Solomon Islands in 2001 to that in 2005?
Your response must be concise. 1.15. What is the ratio of the Value added (constant 2005 US$) in Central Europe in 2002 to that in 2003?
Your answer should be compact. 0.95. What is the ratio of the Value added (constant 2005 US$) in Dominican Republic in 2002 to that in 2003?
Make the answer very short. 1.02. What is the ratio of the Value added (constant 2005 US$) in Singapore in 2002 to that in 2003?
Your answer should be compact. 0.99. What is the ratio of the Value added (constant 2005 US$) in Solomon Islands in 2002 to that in 2003?
Your answer should be compact. 1.08. What is the ratio of the Value added (constant 2005 US$) of Central Europe in 2002 to that in 2004?
Your answer should be compact. 0.88. What is the ratio of the Value added (constant 2005 US$) in Dominican Republic in 2002 to that in 2004?
Keep it short and to the point. 1.02. What is the ratio of the Value added (constant 2005 US$) of Singapore in 2002 to that in 2004?
Your response must be concise. 0.9. What is the ratio of the Value added (constant 2005 US$) in Solomon Islands in 2002 to that in 2004?
Your answer should be compact. 1.16. What is the ratio of the Value added (constant 2005 US$) of Central Europe in 2002 to that in 2005?
Offer a very short reply. 0.84. What is the ratio of the Value added (constant 2005 US$) in Dominican Republic in 2002 to that in 2005?
Provide a short and direct response. 0.96. What is the ratio of the Value added (constant 2005 US$) of Singapore in 2002 to that in 2005?
Your response must be concise. 0.83. What is the ratio of the Value added (constant 2005 US$) of Solomon Islands in 2002 to that in 2005?
Make the answer very short. 1.13. What is the ratio of the Value added (constant 2005 US$) in Central Europe in 2003 to that in 2004?
Keep it short and to the point. 0.93. What is the ratio of the Value added (constant 2005 US$) in Dominican Republic in 2003 to that in 2004?
Provide a succinct answer. 1. What is the ratio of the Value added (constant 2005 US$) of Singapore in 2003 to that in 2004?
Give a very brief answer. 0.91. What is the ratio of the Value added (constant 2005 US$) of Solomon Islands in 2003 to that in 2004?
Ensure brevity in your answer.  1.07. What is the ratio of the Value added (constant 2005 US$) in Central Europe in 2003 to that in 2005?
Give a very brief answer. 0.88. What is the ratio of the Value added (constant 2005 US$) of Dominican Republic in 2003 to that in 2005?
Ensure brevity in your answer.  0.94. What is the ratio of the Value added (constant 2005 US$) of Singapore in 2003 to that in 2005?
Offer a terse response. 0.84. What is the ratio of the Value added (constant 2005 US$) of Solomon Islands in 2003 to that in 2005?
Provide a short and direct response. 1.04. What is the ratio of the Value added (constant 2005 US$) of Central Europe in 2004 to that in 2005?
Your response must be concise. 0.95. What is the ratio of the Value added (constant 2005 US$) in Dominican Republic in 2004 to that in 2005?
Your answer should be compact. 0.94. What is the ratio of the Value added (constant 2005 US$) in Singapore in 2004 to that in 2005?
Provide a short and direct response. 0.93. What is the ratio of the Value added (constant 2005 US$) in Solomon Islands in 2004 to that in 2005?
Provide a short and direct response. 0.97. What is the difference between the highest and the second highest Value added (constant 2005 US$) in Central Europe?
Make the answer very short. 1.25e+1. What is the difference between the highest and the second highest Value added (constant 2005 US$) in Dominican Republic?
Your response must be concise. 3.90e+08. What is the difference between the highest and the second highest Value added (constant 2005 US$) of Singapore?
Make the answer very short. 2.91e+09. What is the difference between the highest and the second highest Value added (constant 2005 US$) in Solomon Islands?
Provide a succinct answer. 3.89e+06. What is the difference between the highest and the lowest Value added (constant 2005 US$) of Central Europe?
Ensure brevity in your answer.  5.17e+1. What is the difference between the highest and the lowest Value added (constant 2005 US$) of Dominican Republic?
Ensure brevity in your answer.  8.30e+08. What is the difference between the highest and the lowest Value added (constant 2005 US$) of Singapore?
Your response must be concise. 8.01e+09. What is the difference between the highest and the lowest Value added (constant 2005 US$) in Solomon Islands?
Your answer should be compact. 9.82e+06. 